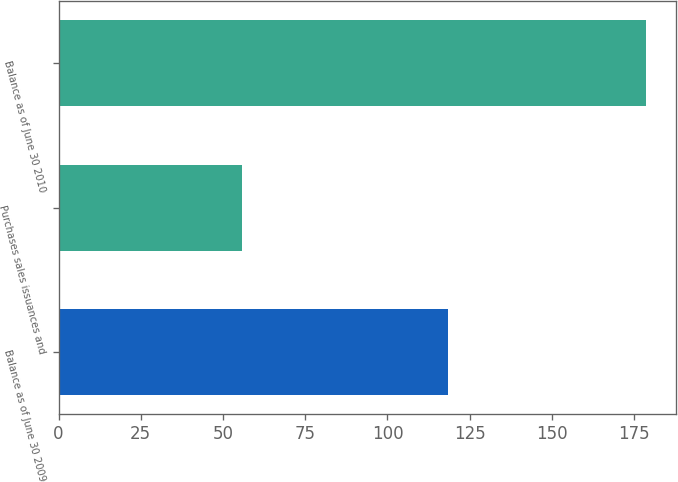<chart> <loc_0><loc_0><loc_500><loc_500><bar_chart><fcel>Balance as of June 30 2009<fcel>Purchases sales issuances and<fcel>Balance as of June 30 2010<nl><fcel>118.4<fcel>55.7<fcel>178.7<nl></chart> 